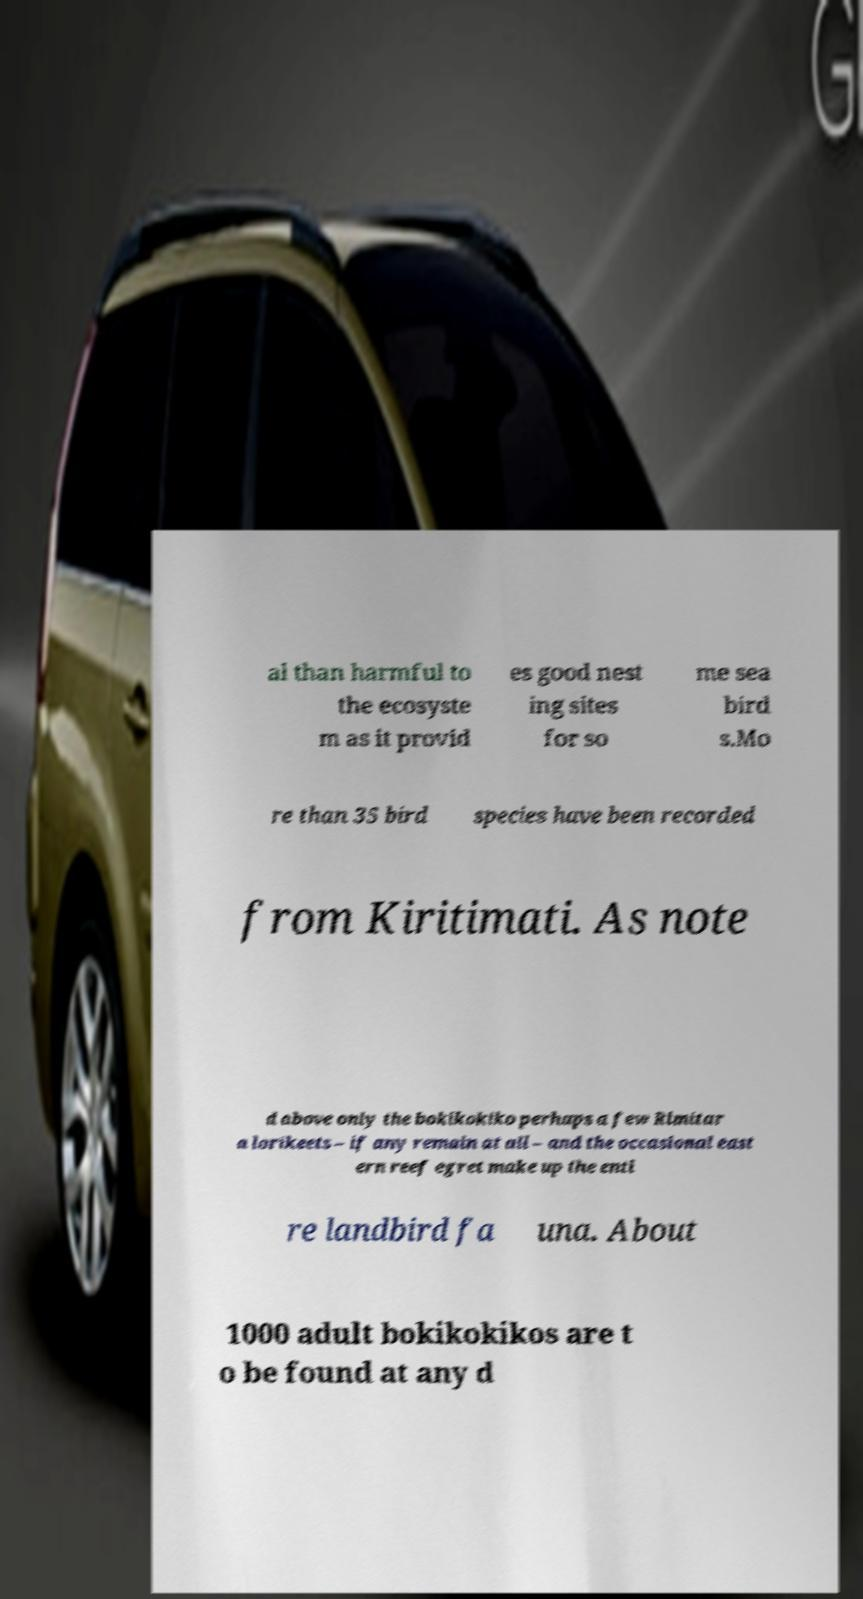Please identify and transcribe the text found in this image. al than harmful to the ecosyste m as it provid es good nest ing sites for so me sea bird s.Mo re than 35 bird species have been recorded from Kiritimati. As note d above only the bokikokiko perhaps a few Rimitar a lorikeets – if any remain at all – and the occasional east ern reef egret make up the enti re landbird fa una. About 1000 adult bokikokikos are t o be found at any d 